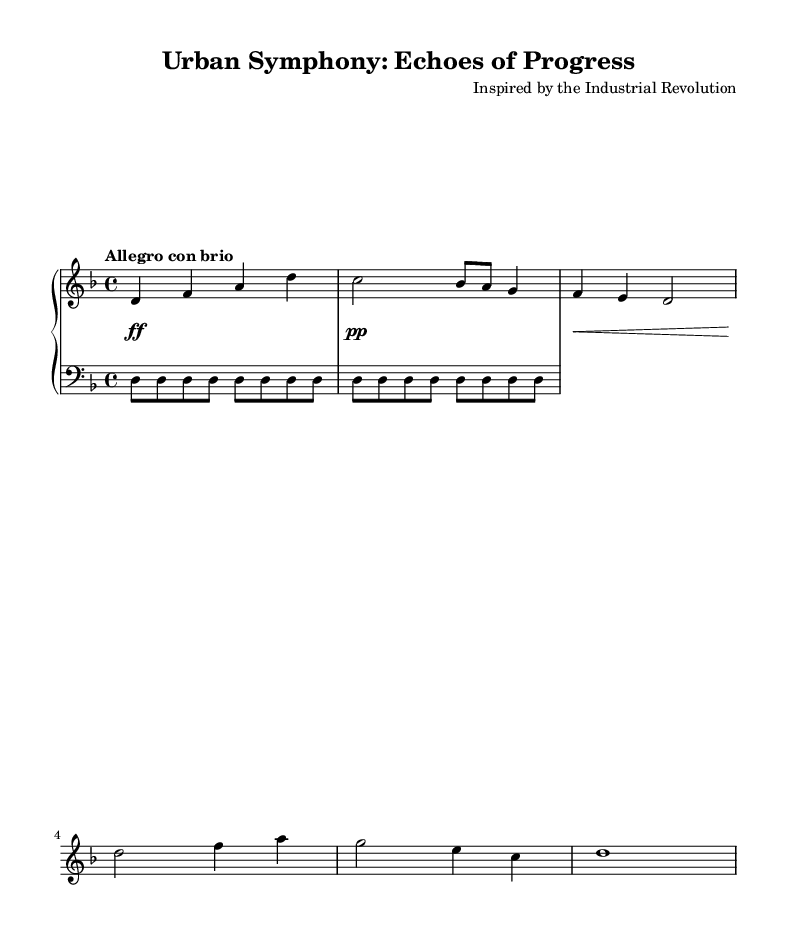What is the key signature of this music? The key signature shows two flats (B♭ and E♭) indicating that the music is in D minor.
Answer: D minor What is the time signature used in this piece? The time signature is shown at the beginning of the score as 4/4, which means there are four beats in each measure and the quarter note gets one beat.
Answer: 4/4 What is the tempo marking for this composition? The tempo marking "Allegro con brio" indicates a fast and spirited pace for the music.
Answer: Allegro con brio What rhythmic element is repeated in the left hand? The left hand features a repeated motif of quarter-note rhythms on the D pitch, symbolizing the repetitive nature of factory work during the Industrial Revolution.
Answer: D How many measures are there in the main melody? The main melody consists of 8 distinct notes crafted into four measures, reflecting traditional structures in Romantic piano music.
Answer: Four What dynamic markings are present in this piece? The dynamic markings indicate contrasts in the music, moving from forte (loud) to piano (soft), emphasizing emotional depth.
Answer: Forte, piano How does the steam whistle motif contribute to the piece? The steam whistle motif is presented as rapid sixteenth notes followed by rests, evoking the industrial sounds that shaped urban landscapes during the time.
Answer: Industrial sounds 